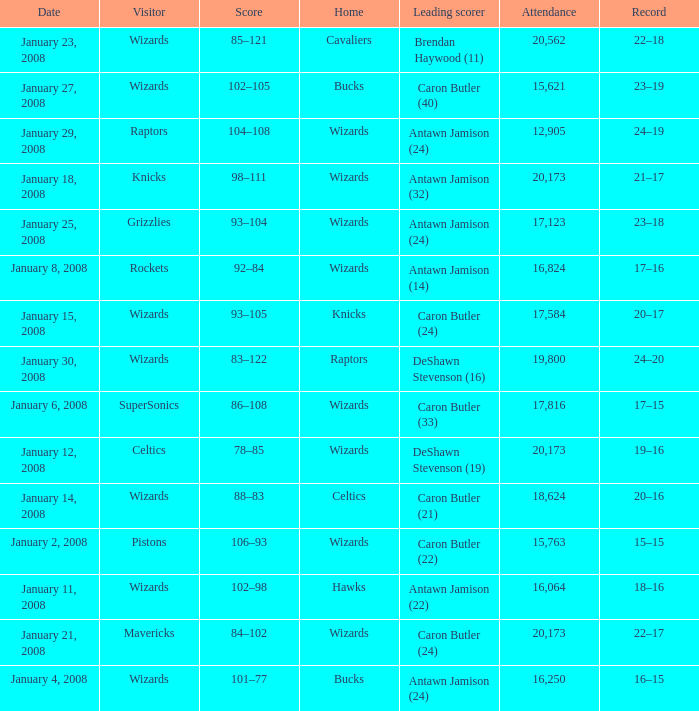How many people were in attendance on January 4, 2008? 16250.0. 